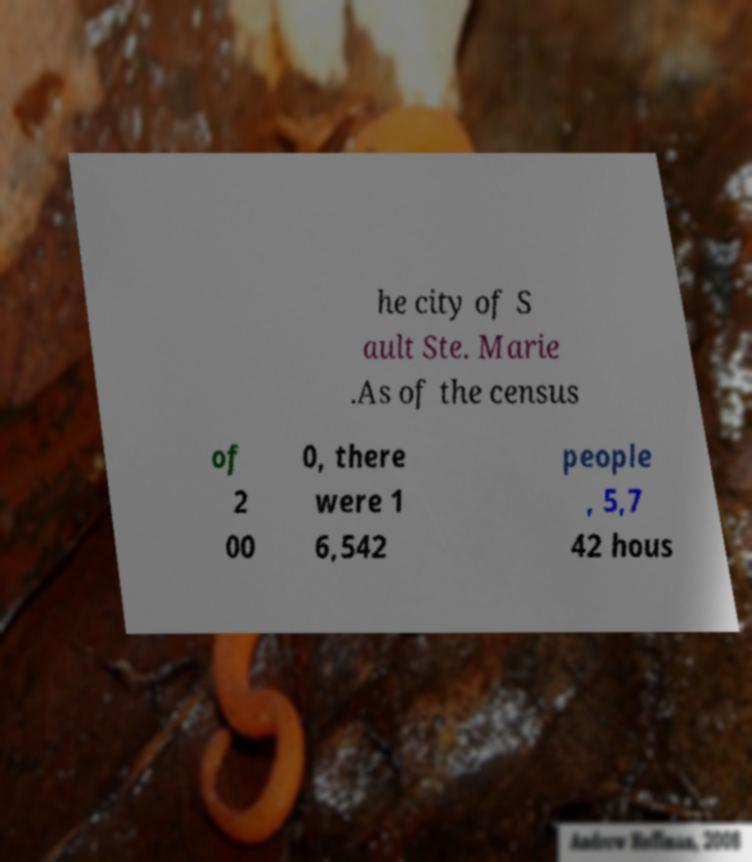I need the written content from this picture converted into text. Can you do that? he city of S ault Ste. Marie .As of the census of 2 00 0, there were 1 6,542 people , 5,7 42 hous 